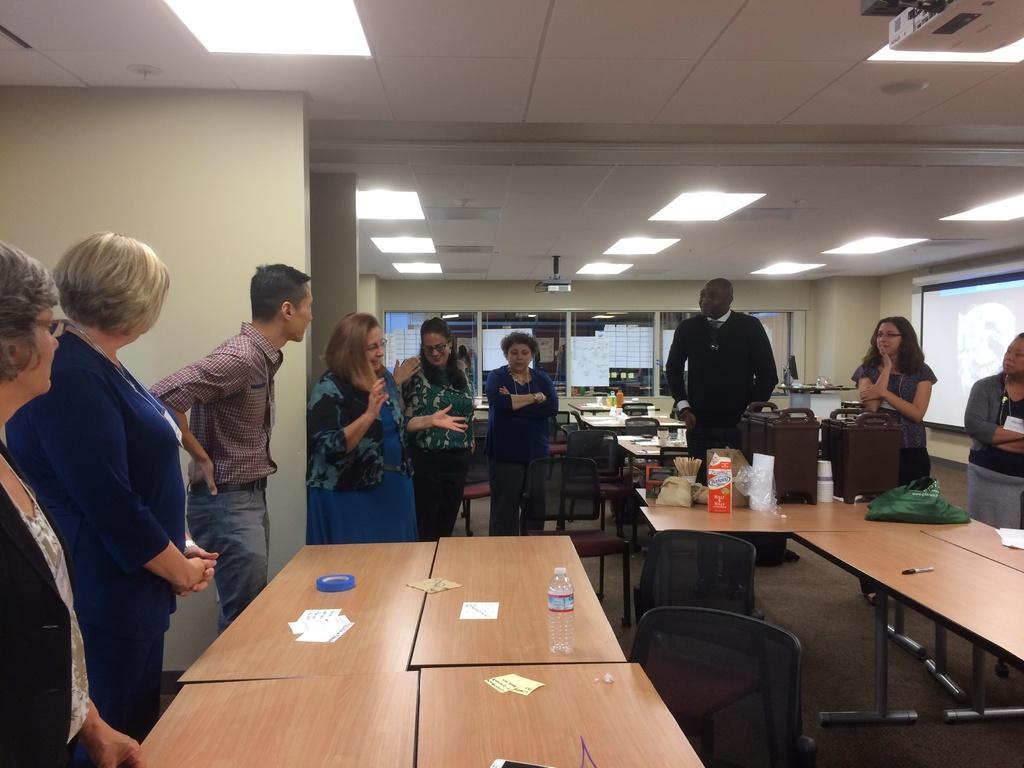Could you give a brief overview of what you see in this image? In the image there are group of people standing in front of a table. On table we can see a water bottle,paper,card,box,cover and there are also few chairs bedside table. On right side we can see a white color screen, on left side we can see a wall which is in cream color. On top there is a roof and few lights. 